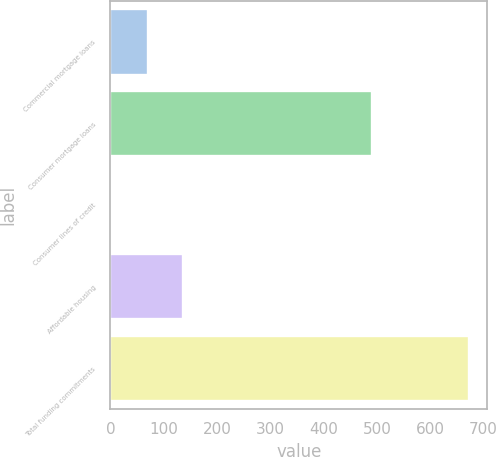Convert chart. <chart><loc_0><loc_0><loc_500><loc_500><bar_chart><fcel>Commercial mortgage loans<fcel>Consumer mortgage loans<fcel>Consumer lines of credit<fcel>Affordable housing<fcel>Total funding commitments<nl><fcel>70<fcel>491<fcel>3<fcel>137<fcel>673<nl></chart> 